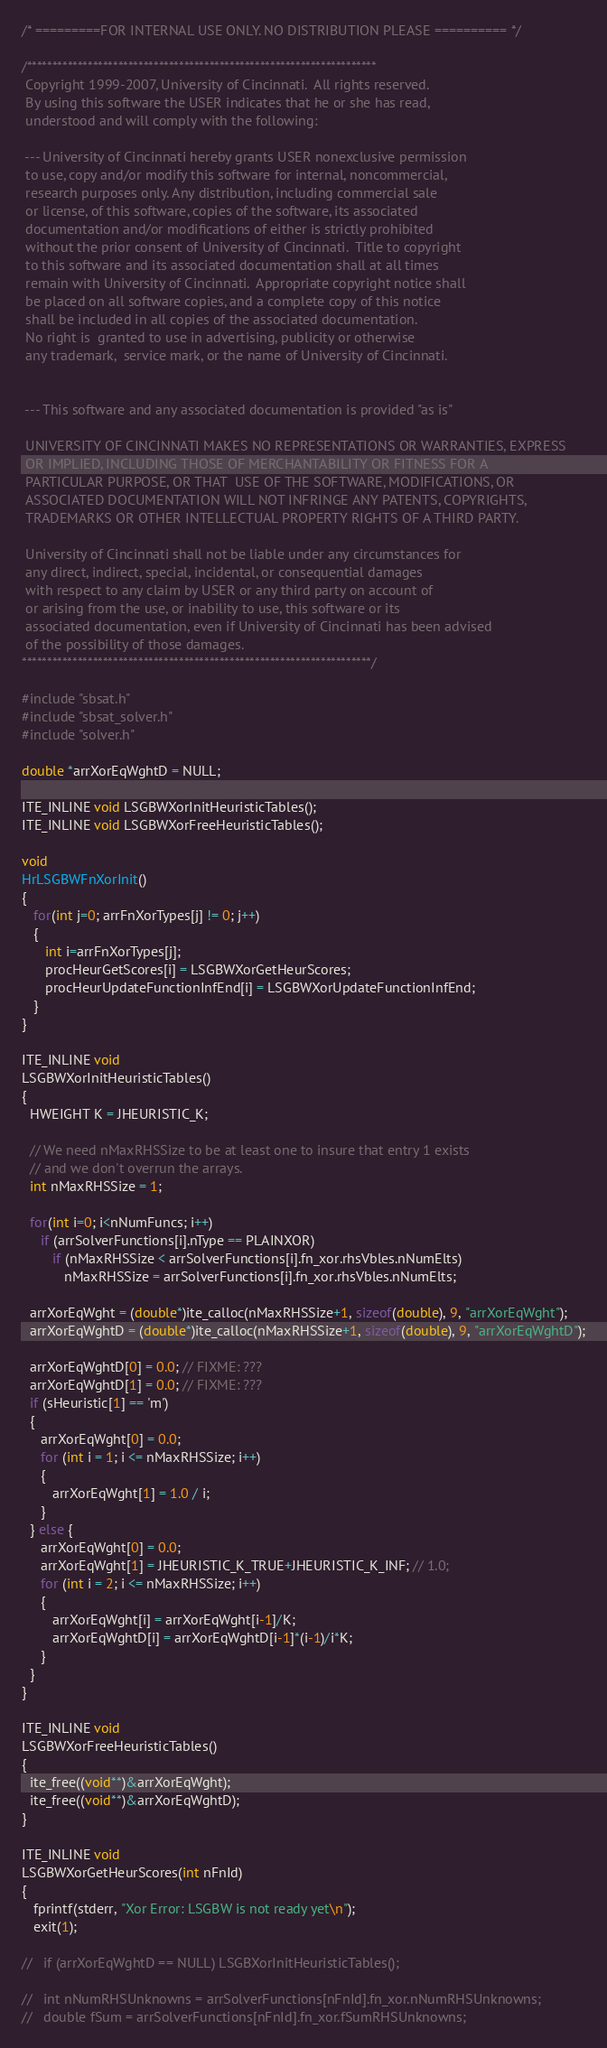Convert code to text. <code><loc_0><loc_0><loc_500><loc_500><_C++_>/* =========FOR INTERNAL USE ONLY. NO DISTRIBUTION PLEASE ========== */

/*********************************************************************
 Copyright 1999-2007, University of Cincinnati.  All rights reserved.
 By using this software the USER indicates that he or she has read,
 understood and will comply with the following:

 --- University of Cincinnati hereby grants USER nonexclusive permission
 to use, copy and/or modify this software for internal, noncommercial,
 research purposes only. Any distribution, including commercial sale
 or license, of this software, copies of the software, its associated
 documentation and/or modifications of either is strictly prohibited
 without the prior consent of University of Cincinnati.  Title to copyright
 to this software and its associated documentation shall at all times
 remain with University of Cincinnati.  Appropriate copyright notice shall
 be placed on all software copies, and a complete copy of this notice
 shall be included in all copies of the associated documentation.
 No right is  granted to use in advertising, publicity or otherwise
 any trademark,  service mark, or the name of University of Cincinnati.


 --- This software and any associated documentation is provided "as is"

 UNIVERSITY OF CINCINNATI MAKES NO REPRESENTATIONS OR WARRANTIES, EXPRESS
 OR IMPLIED, INCLUDING THOSE OF MERCHANTABILITY OR FITNESS FOR A
 PARTICULAR PURPOSE, OR THAT  USE OF THE SOFTWARE, MODIFICATIONS, OR
 ASSOCIATED DOCUMENTATION WILL NOT INFRINGE ANY PATENTS, COPYRIGHTS,
 TRADEMARKS OR OTHER INTELLECTUAL PROPERTY RIGHTS OF A THIRD PARTY.

 University of Cincinnati shall not be liable under any circumstances for
 any direct, indirect, special, incidental, or consequential damages
 with respect to any claim by USER or any third party on account of
 or arising from the use, or inability to use, this software or its
 associated documentation, even if University of Cincinnati has been advised
 of the possibility of those damages.
*********************************************************************/

#include "sbsat.h"
#include "sbsat_solver.h"
#include "solver.h"

double *arrXorEqWghtD = NULL;

ITE_INLINE void LSGBWXorInitHeuristicTables();
ITE_INLINE void LSGBWXorFreeHeuristicTables();

void
HrLSGBWFnXorInit()
{
   for(int j=0; arrFnXorTypes[j] != 0; j++)
   {
      int i=arrFnXorTypes[j];
      procHeurGetScores[i] = LSGBWXorGetHeurScores;
      procHeurUpdateFunctionInfEnd[i] = LSGBWXorUpdateFunctionInfEnd;
   }
}

ITE_INLINE void
LSGBWXorInitHeuristicTables()
{
  HWEIGHT K = JHEURISTIC_K;

  // We need nMaxRHSSize to be at least one to insure that entry 1 exists
  // and we don't overrun the arrays.
  int nMaxRHSSize = 1;

  for(int i=0; i<nNumFuncs; i++) 
     if (arrSolverFunctions[i].nType == PLAINXOR)
        if (nMaxRHSSize < arrSolverFunctions[i].fn_xor.rhsVbles.nNumElts)
           nMaxRHSSize = arrSolverFunctions[i].fn_xor.rhsVbles.nNumElts;

  arrXorEqWght = (double*)ite_calloc(nMaxRHSSize+1, sizeof(double), 9, "arrXorEqWght");
  arrXorEqWghtD = (double*)ite_calloc(nMaxRHSSize+1, sizeof(double), 9, "arrXorEqWghtD");

  arrXorEqWghtD[0] = 0.0; // FIXME: ???
  arrXorEqWghtD[1] = 0.0; // FIXME: ???
  if (sHeuristic[1] == 'm') 
  {
     arrXorEqWght[0] = 0.0;
     for (int i = 1; i <= nMaxRHSSize; i++)
     {
        arrXorEqWght[1] = 1.0 / i;
     }
  } else {
     arrXorEqWght[0] = 0.0;
     arrXorEqWght[1] = JHEURISTIC_K_TRUE+JHEURISTIC_K_INF; // 1.0;
     for (int i = 2; i <= nMaxRHSSize; i++)
     {
        arrXorEqWght[i] = arrXorEqWght[i-1]/K;
        arrXorEqWghtD[i] = arrXorEqWghtD[i-1]*(i-1)/i*K;
     }
  }
}

ITE_INLINE void
LSGBWXorFreeHeuristicTables()
{
  ite_free((void**)&arrXorEqWght);
  ite_free((void**)&arrXorEqWghtD);
}

ITE_INLINE void
LSGBWXorGetHeurScores(int nFnId)
{
   fprintf(stderr, "Xor Error: LSGBW is not ready yet\n");
   exit(1);

//   if (arrXorEqWghtD == NULL) LSGBXorInitHeuristicTables();

//   int nNumRHSUnknowns = arrSolverFunctions[nFnId].fn_xor.nNumRHSUnknowns;
//   double fSum = arrSolverFunctions[nFnId].fn_xor.fSumRHSUnknowns;
</code> 